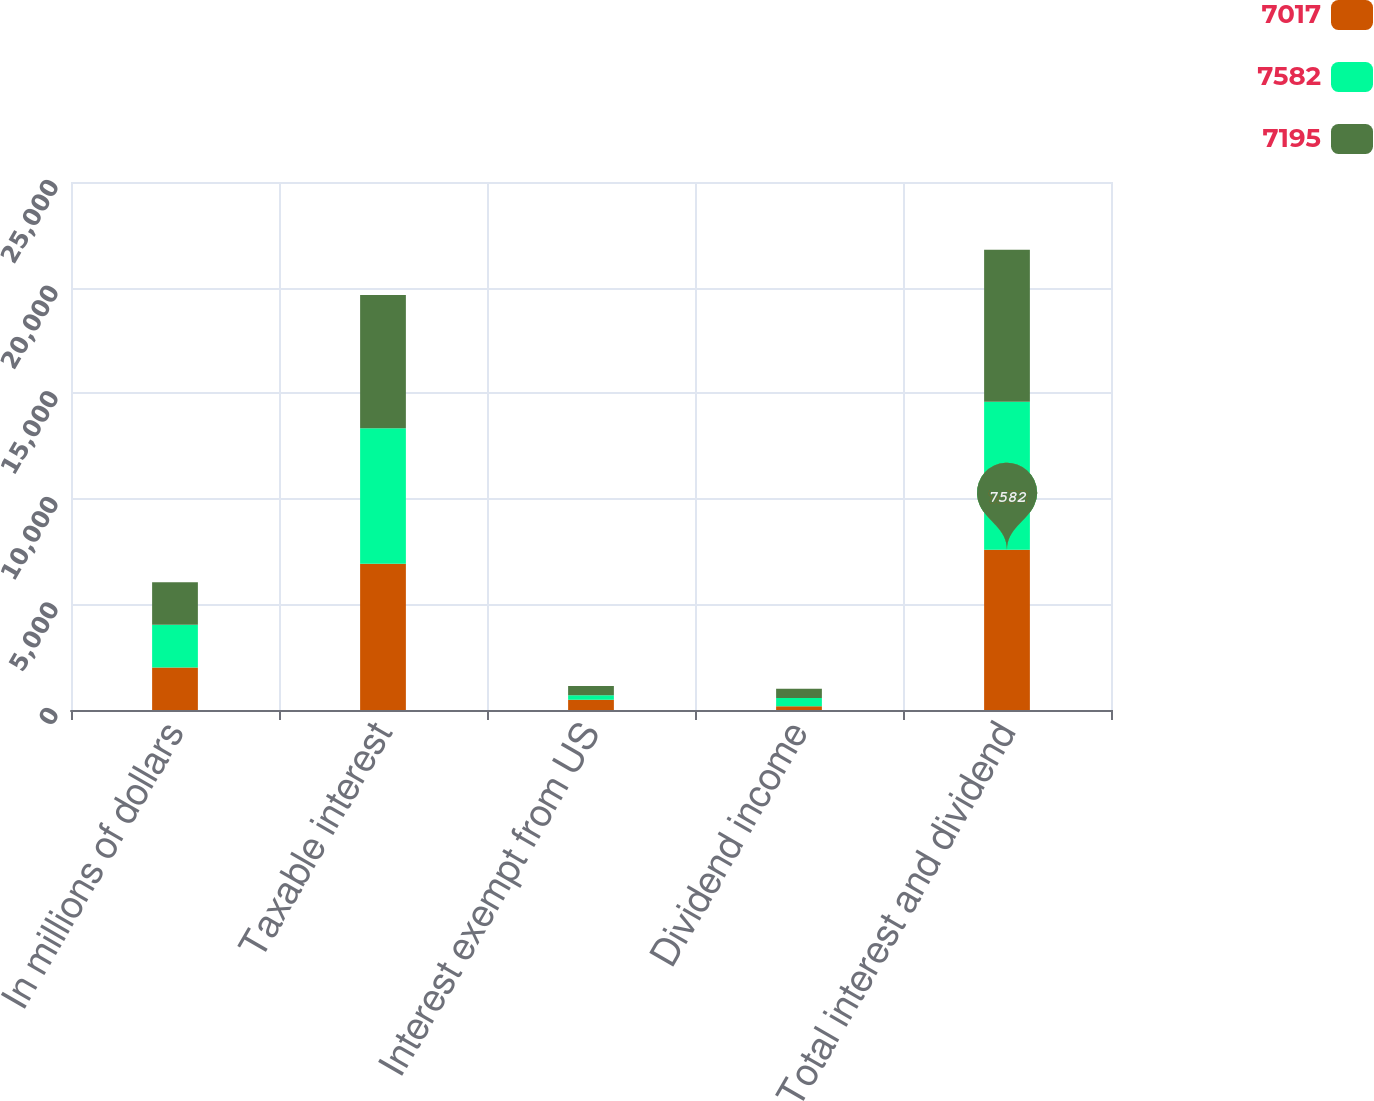Convert chart. <chart><loc_0><loc_0><loc_500><loc_500><stacked_bar_chart><ecel><fcel>In millions of dollars<fcel>Taxable interest<fcel>Interest exempt from US<fcel>Dividend income<fcel>Total interest and dividend<nl><fcel>7017<fcel>2016<fcel>6924<fcel>483<fcel>175<fcel>7582<nl><fcel>7582<fcel>2015<fcel>6414<fcel>215<fcel>388<fcel>7017<nl><fcel>7195<fcel>2014<fcel>6311<fcel>439<fcel>445<fcel>7195<nl></chart> 